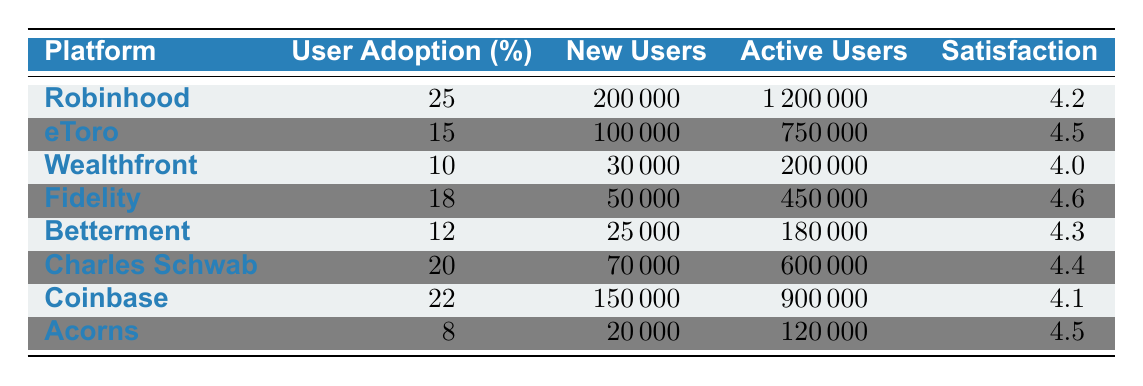What is the user adoption rate of Robinhood in Q4? The table lists the user adoption rate for each platform. For Robinhood, it is explicitly stated next to it in the table.
Answer: 25% Which platform has the highest number of new users in Q4? By comparing the "New Users" column for all platforms, Robinhood shows the highest value with 200,000 new users.
Answer: Robinhood What is the average user satisfaction score across all platforms? The satisfaction scores are: 4.2, 4.5, 4.0, 4.6, 4.3, 4.4, 4.1, and 4.5. Summing these scores gives a total of 34.2, and dividing by the number of platforms, which is 8, results in an average of 34.2/8 = 4.275.
Answer: 4.275 Does eToro have a higher user satisfaction score than Wealthfront? The satisfaction score for eToro is 4.5 while for Wealthfront it is 4.0. Comparing these scores shows that eToro indeed has a higher score.
Answer: Yes Which two platforms have the same number of new users, and what is that number? Looking at the "New Users" column, it's clear that Betterment and Acorns have the lowest count of new users. Betterment has 25,000 and Acorns has 20,000, and no two platforms have the same number of new users.
Answer: None What is the difference in user adoption rates between Fidelity and Charles Schwab? The user adoption rate for Fidelity is 18%, and for Charles Schwab, it is 20%. The difference can be calculated as 20% - 18% = 2%.
Answer: 2% What proportion of active users does Coinbase have compared to Robinhood? Coinbase has 900,000 active users while Robinhood has 1,200,000. The proportion can be calculated as 900,000 / 1,200,000 = 0.75, indicating Coinbase has 75% of Robinhood's active users.
Answer: 75% Which platform has the lowest user adoption rate, and what is the score? By examining the "User Adoption" column, Acorns has the lowest score of 8%, indicating the least user adoption out of all listed platforms.
Answer: Acorns, 8% 